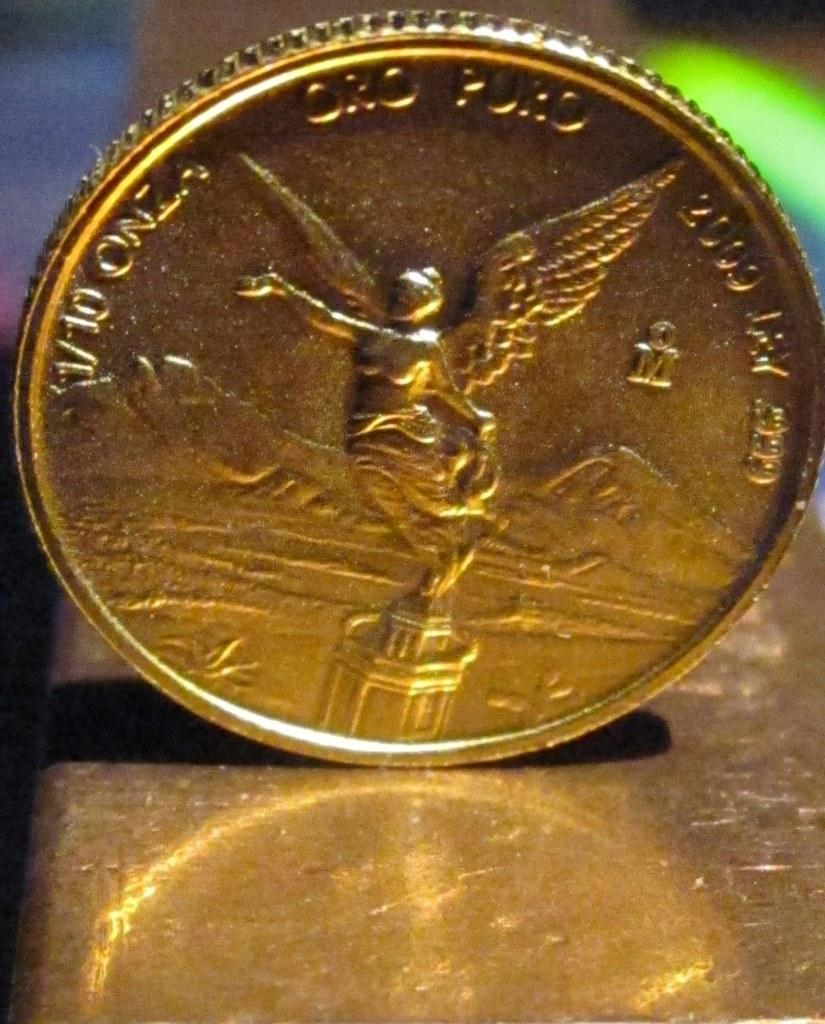<image>
Render a clear and concise summary of the photo. A gold Oro Puro coin with an angel from 2009. 